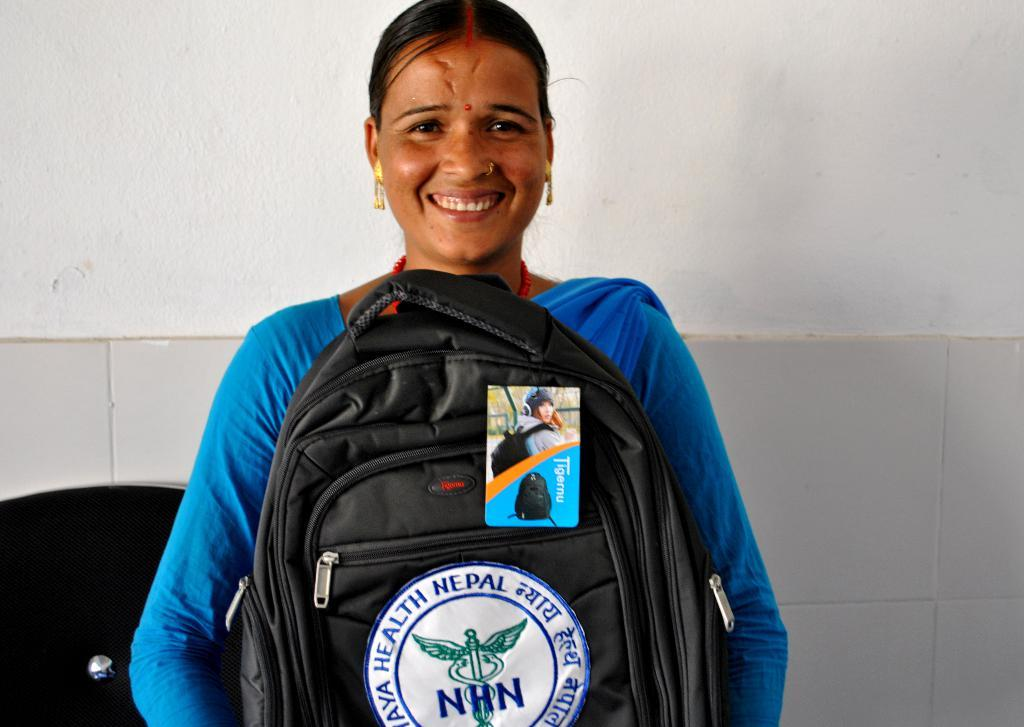Provide a one-sentence caption for the provided image. A lady wearing blue who is smiling and holding a black backpack with a tag and decal with NHN and a medical logo on it. 